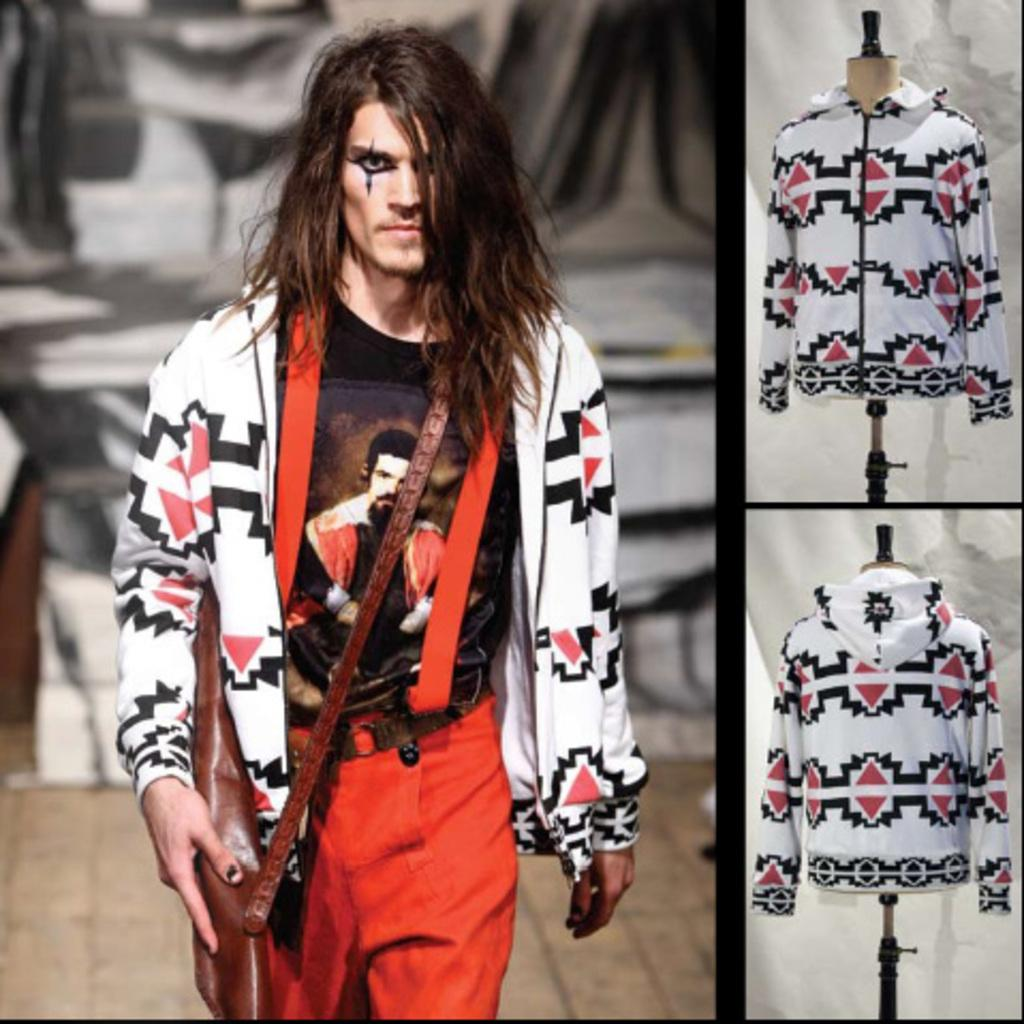What is the person in the image doing? The person is walking in the image. What is the person holding while walking? The person is holding a brown object. What can be seen on the right side of the image? There are clothes on the right side of the image. What is visible in the background of the image? There is a wall in the background of the image. How many family members can be seen in the image during the week? There is no reference to a family or a specific time in the image, so it is not possible to determine the number of family members or the day of the week. 